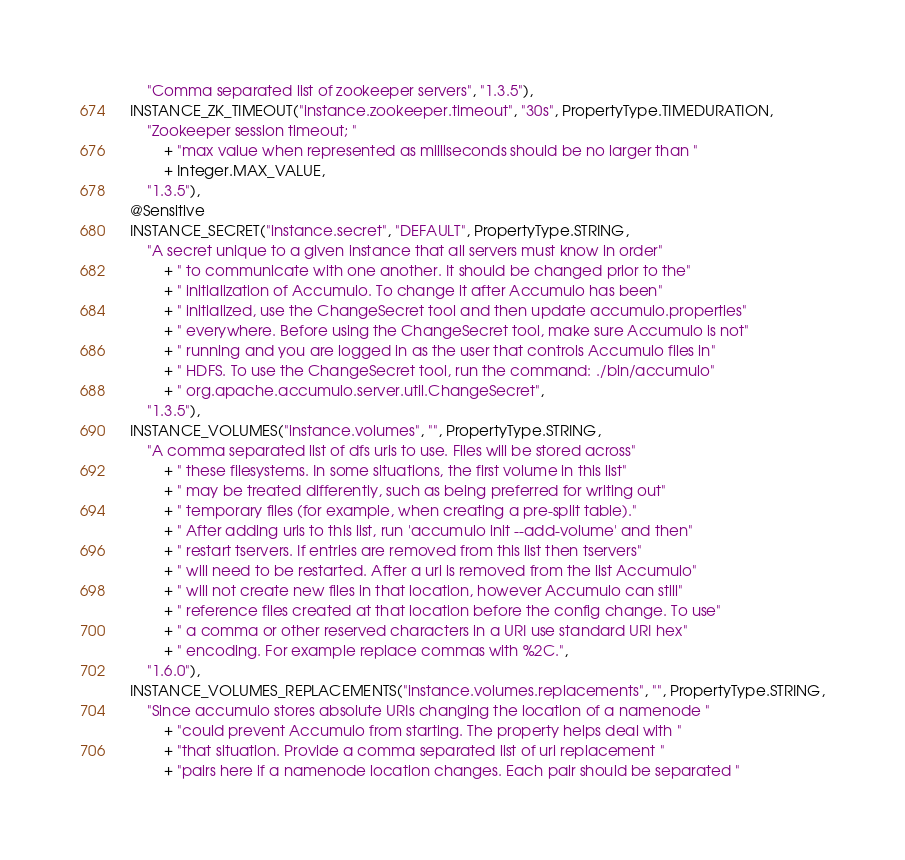Convert code to text. <code><loc_0><loc_0><loc_500><loc_500><_Java_>      "Comma separated list of zookeeper servers", "1.3.5"),
  INSTANCE_ZK_TIMEOUT("instance.zookeeper.timeout", "30s", PropertyType.TIMEDURATION,
      "Zookeeper session timeout; "
          + "max value when represented as milliseconds should be no larger than "
          + Integer.MAX_VALUE,
      "1.3.5"),
  @Sensitive
  INSTANCE_SECRET("instance.secret", "DEFAULT", PropertyType.STRING,
      "A secret unique to a given instance that all servers must know in order"
          + " to communicate with one another. It should be changed prior to the"
          + " initialization of Accumulo. To change it after Accumulo has been"
          + " initialized, use the ChangeSecret tool and then update accumulo.properties"
          + " everywhere. Before using the ChangeSecret tool, make sure Accumulo is not"
          + " running and you are logged in as the user that controls Accumulo files in"
          + " HDFS. To use the ChangeSecret tool, run the command: ./bin/accumulo"
          + " org.apache.accumulo.server.util.ChangeSecret",
      "1.3.5"),
  INSTANCE_VOLUMES("instance.volumes", "", PropertyType.STRING,
      "A comma separated list of dfs uris to use. Files will be stored across"
          + " these filesystems. In some situations, the first volume in this list"
          + " may be treated differently, such as being preferred for writing out"
          + " temporary files (for example, when creating a pre-split table)."
          + " After adding uris to this list, run 'accumulo init --add-volume' and then"
          + " restart tservers. If entries are removed from this list then tservers"
          + " will need to be restarted. After a uri is removed from the list Accumulo"
          + " will not create new files in that location, however Accumulo can still"
          + " reference files created at that location before the config change. To use"
          + " a comma or other reserved characters in a URI use standard URI hex"
          + " encoding. For example replace commas with %2C.",
      "1.6.0"),
  INSTANCE_VOLUMES_REPLACEMENTS("instance.volumes.replacements", "", PropertyType.STRING,
      "Since accumulo stores absolute URIs changing the location of a namenode "
          + "could prevent Accumulo from starting. The property helps deal with "
          + "that situation. Provide a comma separated list of uri replacement "
          + "pairs here if a namenode location changes. Each pair should be separated "</code> 